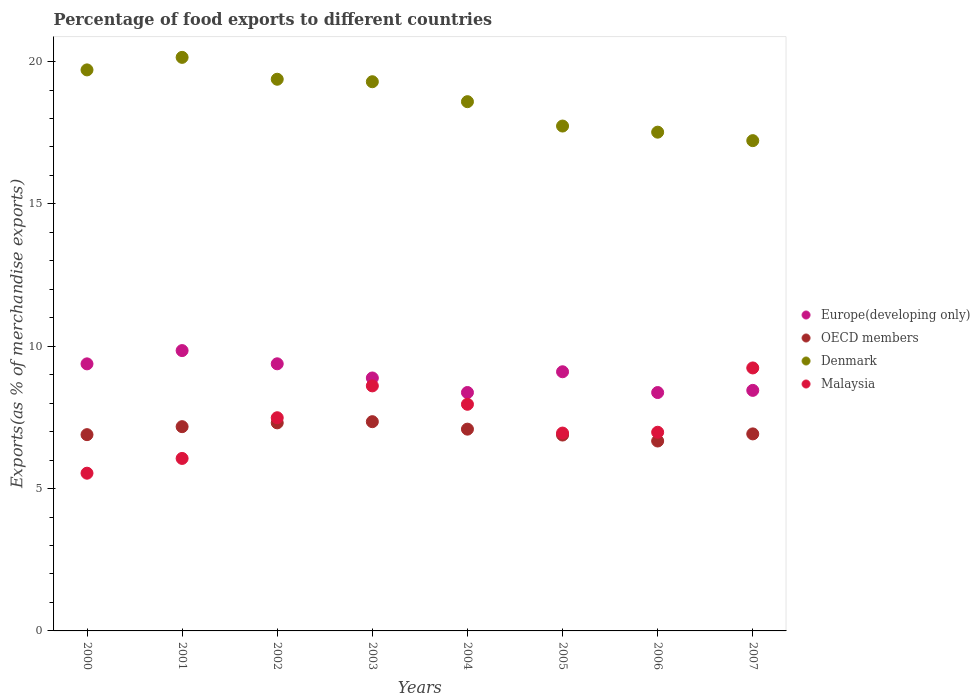What is the percentage of exports to different countries in Malaysia in 2000?
Your answer should be very brief. 5.54. Across all years, what is the maximum percentage of exports to different countries in Denmark?
Provide a succinct answer. 20.15. Across all years, what is the minimum percentage of exports to different countries in Denmark?
Provide a short and direct response. 17.22. In which year was the percentage of exports to different countries in Denmark maximum?
Offer a very short reply. 2001. What is the total percentage of exports to different countries in OECD members in the graph?
Offer a terse response. 56.29. What is the difference between the percentage of exports to different countries in Malaysia in 2001 and that in 2003?
Offer a terse response. -2.55. What is the difference between the percentage of exports to different countries in Malaysia in 2001 and the percentage of exports to different countries in Europe(developing only) in 2007?
Your answer should be compact. -2.39. What is the average percentage of exports to different countries in Europe(developing only) per year?
Give a very brief answer. 8.97. In the year 2001, what is the difference between the percentage of exports to different countries in Denmark and percentage of exports to different countries in OECD members?
Offer a very short reply. 12.97. What is the ratio of the percentage of exports to different countries in Malaysia in 2001 to that in 2007?
Provide a short and direct response. 0.66. Is the percentage of exports to different countries in Malaysia in 2000 less than that in 2007?
Provide a short and direct response. Yes. What is the difference between the highest and the second highest percentage of exports to different countries in OECD members?
Ensure brevity in your answer.  0.04. What is the difference between the highest and the lowest percentage of exports to different countries in Europe(developing only)?
Your answer should be compact. 1.47. Is the sum of the percentage of exports to different countries in Malaysia in 2006 and 2007 greater than the maximum percentage of exports to different countries in Denmark across all years?
Ensure brevity in your answer.  No. Is it the case that in every year, the sum of the percentage of exports to different countries in Europe(developing only) and percentage of exports to different countries in OECD members  is greater than the sum of percentage of exports to different countries in Denmark and percentage of exports to different countries in Malaysia?
Provide a short and direct response. Yes. Is the percentage of exports to different countries in Europe(developing only) strictly greater than the percentage of exports to different countries in Denmark over the years?
Give a very brief answer. No. How many years are there in the graph?
Your response must be concise. 8. Does the graph contain grids?
Your answer should be very brief. No. Where does the legend appear in the graph?
Your answer should be very brief. Center right. What is the title of the graph?
Ensure brevity in your answer.  Percentage of food exports to different countries. Does "Morocco" appear as one of the legend labels in the graph?
Offer a terse response. No. What is the label or title of the Y-axis?
Keep it short and to the point. Exports(as % of merchandise exports). What is the Exports(as % of merchandise exports) of Europe(developing only) in 2000?
Offer a terse response. 9.38. What is the Exports(as % of merchandise exports) in OECD members in 2000?
Offer a very short reply. 6.89. What is the Exports(as % of merchandise exports) in Denmark in 2000?
Make the answer very short. 19.71. What is the Exports(as % of merchandise exports) of Malaysia in 2000?
Offer a very short reply. 5.54. What is the Exports(as % of merchandise exports) of Europe(developing only) in 2001?
Offer a very short reply. 9.85. What is the Exports(as % of merchandise exports) in OECD members in 2001?
Your answer should be compact. 7.17. What is the Exports(as % of merchandise exports) of Denmark in 2001?
Make the answer very short. 20.15. What is the Exports(as % of merchandise exports) of Malaysia in 2001?
Give a very brief answer. 6.06. What is the Exports(as % of merchandise exports) in Europe(developing only) in 2002?
Give a very brief answer. 9.38. What is the Exports(as % of merchandise exports) of OECD members in 2002?
Ensure brevity in your answer.  7.31. What is the Exports(as % of merchandise exports) in Denmark in 2002?
Your answer should be very brief. 19.38. What is the Exports(as % of merchandise exports) in Malaysia in 2002?
Make the answer very short. 7.49. What is the Exports(as % of merchandise exports) of Europe(developing only) in 2003?
Ensure brevity in your answer.  8.89. What is the Exports(as % of merchandise exports) of OECD members in 2003?
Your answer should be very brief. 7.35. What is the Exports(as % of merchandise exports) of Denmark in 2003?
Provide a short and direct response. 19.29. What is the Exports(as % of merchandise exports) in Malaysia in 2003?
Provide a succinct answer. 8.61. What is the Exports(as % of merchandise exports) in Europe(developing only) in 2004?
Your answer should be compact. 8.37. What is the Exports(as % of merchandise exports) of OECD members in 2004?
Your response must be concise. 7.09. What is the Exports(as % of merchandise exports) of Denmark in 2004?
Make the answer very short. 18.59. What is the Exports(as % of merchandise exports) in Malaysia in 2004?
Ensure brevity in your answer.  7.96. What is the Exports(as % of merchandise exports) in Europe(developing only) in 2005?
Provide a short and direct response. 9.1. What is the Exports(as % of merchandise exports) of OECD members in 2005?
Your answer should be very brief. 6.88. What is the Exports(as % of merchandise exports) in Denmark in 2005?
Offer a terse response. 17.73. What is the Exports(as % of merchandise exports) of Malaysia in 2005?
Your response must be concise. 6.95. What is the Exports(as % of merchandise exports) in Europe(developing only) in 2006?
Make the answer very short. 8.37. What is the Exports(as % of merchandise exports) of OECD members in 2006?
Provide a short and direct response. 6.67. What is the Exports(as % of merchandise exports) in Denmark in 2006?
Ensure brevity in your answer.  17.52. What is the Exports(as % of merchandise exports) in Malaysia in 2006?
Your answer should be compact. 6.98. What is the Exports(as % of merchandise exports) of Europe(developing only) in 2007?
Offer a very short reply. 8.45. What is the Exports(as % of merchandise exports) of OECD members in 2007?
Ensure brevity in your answer.  6.92. What is the Exports(as % of merchandise exports) of Denmark in 2007?
Provide a short and direct response. 17.22. What is the Exports(as % of merchandise exports) of Malaysia in 2007?
Give a very brief answer. 9.24. Across all years, what is the maximum Exports(as % of merchandise exports) of Europe(developing only)?
Make the answer very short. 9.85. Across all years, what is the maximum Exports(as % of merchandise exports) of OECD members?
Provide a succinct answer. 7.35. Across all years, what is the maximum Exports(as % of merchandise exports) of Denmark?
Your answer should be very brief. 20.15. Across all years, what is the maximum Exports(as % of merchandise exports) of Malaysia?
Make the answer very short. 9.24. Across all years, what is the minimum Exports(as % of merchandise exports) of Europe(developing only)?
Keep it short and to the point. 8.37. Across all years, what is the minimum Exports(as % of merchandise exports) of OECD members?
Your answer should be very brief. 6.67. Across all years, what is the minimum Exports(as % of merchandise exports) in Denmark?
Keep it short and to the point. 17.22. Across all years, what is the minimum Exports(as % of merchandise exports) in Malaysia?
Give a very brief answer. 5.54. What is the total Exports(as % of merchandise exports) of Europe(developing only) in the graph?
Provide a short and direct response. 71.8. What is the total Exports(as % of merchandise exports) of OECD members in the graph?
Keep it short and to the point. 56.29. What is the total Exports(as % of merchandise exports) in Denmark in the graph?
Your answer should be very brief. 149.59. What is the total Exports(as % of merchandise exports) of Malaysia in the graph?
Ensure brevity in your answer.  58.82. What is the difference between the Exports(as % of merchandise exports) in Europe(developing only) in 2000 and that in 2001?
Provide a short and direct response. -0.47. What is the difference between the Exports(as % of merchandise exports) of OECD members in 2000 and that in 2001?
Make the answer very short. -0.28. What is the difference between the Exports(as % of merchandise exports) of Denmark in 2000 and that in 2001?
Your answer should be compact. -0.44. What is the difference between the Exports(as % of merchandise exports) in Malaysia in 2000 and that in 2001?
Keep it short and to the point. -0.52. What is the difference between the Exports(as % of merchandise exports) of Europe(developing only) in 2000 and that in 2002?
Offer a terse response. -0. What is the difference between the Exports(as % of merchandise exports) of OECD members in 2000 and that in 2002?
Your answer should be very brief. -0.41. What is the difference between the Exports(as % of merchandise exports) of Denmark in 2000 and that in 2002?
Your answer should be compact. 0.33. What is the difference between the Exports(as % of merchandise exports) of Malaysia in 2000 and that in 2002?
Your answer should be compact. -1.95. What is the difference between the Exports(as % of merchandise exports) of Europe(developing only) in 2000 and that in 2003?
Your answer should be compact. 0.5. What is the difference between the Exports(as % of merchandise exports) of OECD members in 2000 and that in 2003?
Offer a terse response. -0.46. What is the difference between the Exports(as % of merchandise exports) in Denmark in 2000 and that in 2003?
Make the answer very short. 0.42. What is the difference between the Exports(as % of merchandise exports) in Malaysia in 2000 and that in 2003?
Provide a short and direct response. -3.07. What is the difference between the Exports(as % of merchandise exports) in OECD members in 2000 and that in 2004?
Make the answer very short. -0.19. What is the difference between the Exports(as % of merchandise exports) in Denmark in 2000 and that in 2004?
Give a very brief answer. 1.12. What is the difference between the Exports(as % of merchandise exports) of Malaysia in 2000 and that in 2004?
Your answer should be compact. -2.42. What is the difference between the Exports(as % of merchandise exports) of Europe(developing only) in 2000 and that in 2005?
Offer a very short reply. 0.28. What is the difference between the Exports(as % of merchandise exports) in OECD members in 2000 and that in 2005?
Your answer should be very brief. 0.01. What is the difference between the Exports(as % of merchandise exports) in Denmark in 2000 and that in 2005?
Offer a very short reply. 1.97. What is the difference between the Exports(as % of merchandise exports) in Malaysia in 2000 and that in 2005?
Provide a short and direct response. -1.41. What is the difference between the Exports(as % of merchandise exports) of Europe(developing only) in 2000 and that in 2006?
Provide a short and direct response. 1.01. What is the difference between the Exports(as % of merchandise exports) of OECD members in 2000 and that in 2006?
Provide a short and direct response. 0.22. What is the difference between the Exports(as % of merchandise exports) in Denmark in 2000 and that in 2006?
Your response must be concise. 2.19. What is the difference between the Exports(as % of merchandise exports) of Malaysia in 2000 and that in 2006?
Your answer should be compact. -1.44. What is the difference between the Exports(as % of merchandise exports) in Europe(developing only) in 2000 and that in 2007?
Provide a short and direct response. 0.93. What is the difference between the Exports(as % of merchandise exports) of OECD members in 2000 and that in 2007?
Give a very brief answer. -0.03. What is the difference between the Exports(as % of merchandise exports) in Denmark in 2000 and that in 2007?
Give a very brief answer. 2.49. What is the difference between the Exports(as % of merchandise exports) in Malaysia in 2000 and that in 2007?
Provide a short and direct response. -3.7. What is the difference between the Exports(as % of merchandise exports) of Europe(developing only) in 2001 and that in 2002?
Give a very brief answer. 0.46. What is the difference between the Exports(as % of merchandise exports) of OECD members in 2001 and that in 2002?
Keep it short and to the point. -0.13. What is the difference between the Exports(as % of merchandise exports) in Denmark in 2001 and that in 2002?
Keep it short and to the point. 0.77. What is the difference between the Exports(as % of merchandise exports) of Malaysia in 2001 and that in 2002?
Your answer should be compact. -1.43. What is the difference between the Exports(as % of merchandise exports) in Europe(developing only) in 2001 and that in 2003?
Your response must be concise. 0.96. What is the difference between the Exports(as % of merchandise exports) of OECD members in 2001 and that in 2003?
Provide a succinct answer. -0.18. What is the difference between the Exports(as % of merchandise exports) of Denmark in 2001 and that in 2003?
Offer a very short reply. 0.86. What is the difference between the Exports(as % of merchandise exports) in Malaysia in 2001 and that in 2003?
Offer a very short reply. -2.55. What is the difference between the Exports(as % of merchandise exports) in Europe(developing only) in 2001 and that in 2004?
Make the answer very short. 1.47. What is the difference between the Exports(as % of merchandise exports) in OECD members in 2001 and that in 2004?
Provide a succinct answer. 0.09. What is the difference between the Exports(as % of merchandise exports) of Denmark in 2001 and that in 2004?
Give a very brief answer. 1.56. What is the difference between the Exports(as % of merchandise exports) of Malaysia in 2001 and that in 2004?
Your answer should be compact. -1.9. What is the difference between the Exports(as % of merchandise exports) of Europe(developing only) in 2001 and that in 2005?
Provide a succinct answer. 0.74. What is the difference between the Exports(as % of merchandise exports) in OECD members in 2001 and that in 2005?
Provide a succinct answer. 0.29. What is the difference between the Exports(as % of merchandise exports) of Denmark in 2001 and that in 2005?
Provide a succinct answer. 2.41. What is the difference between the Exports(as % of merchandise exports) of Malaysia in 2001 and that in 2005?
Give a very brief answer. -0.89. What is the difference between the Exports(as % of merchandise exports) of Europe(developing only) in 2001 and that in 2006?
Provide a short and direct response. 1.47. What is the difference between the Exports(as % of merchandise exports) in OECD members in 2001 and that in 2006?
Your response must be concise. 0.5. What is the difference between the Exports(as % of merchandise exports) of Denmark in 2001 and that in 2006?
Make the answer very short. 2.63. What is the difference between the Exports(as % of merchandise exports) of Malaysia in 2001 and that in 2006?
Provide a succinct answer. -0.92. What is the difference between the Exports(as % of merchandise exports) in Europe(developing only) in 2001 and that in 2007?
Give a very brief answer. 1.4. What is the difference between the Exports(as % of merchandise exports) in OECD members in 2001 and that in 2007?
Offer a very short reply. 0.25. What is the difference between the Exports(as % of merchandise exports) of Denmark in 2001 and that in 2007?
Keep it short and to the point. 2.93. What is the difference between the Exports(as % of merchandise exports) of Malaysia in 2001 and that in 2007?
Offer a very short reply. -3.18. What is the difference between the Exports(as % of merchandise exports) of Europe(developing only) in 2002 and that in 2003?
Keep it short and to the point. 0.5. What is the difference between the Exports(as % of merchandise exports) of OECD members in 2002 and that in 2003?
Ensure brevity in your answer.  -0.04. What is the difference between the Exports(as % of merchandise exports) of Denmark in 2002 and that in 2003?
Offer a terse response. 0.09. What is the difference between the Exports(as % of merchandise exports) in Malaysia in 2002 and that in 2003?
Provide a succinct answer. -1.12. What is the difference between the Exports(as % of merchandise exports) of Europe(developing only) in 2002 and that in 2004?
Your answer should be very brief. 1.01. What is the difference between the Exports(as % of merchandise exports) in OECD members in 2002 and that in 2004?
Provide a short and direct response. 0.22. What is the difference between the Exports(as % of merchandise exports) in Denmark in 2002 and that in 2004?
Your response must be concise. 0.79. What is the difference between the Exports(as % of merchandise exports) of Malaysia in 2002 and that in 2004?
Provide a succinct answer. -0.47. What is the difference between the Exports(as % of merchandise exports) of Europe(developing only) in 2002 and that in 2005?
Make the answer very short. 0.28. What is the difference between the Exports(as % of merchandise exports) of OECD members in 2002 and that in 2005?
Offer a terse response. 0.43. What is the difference between the Exports(as % of merchandise exports) of Denmark in 2002 and that in 2005?
Provide a short and direct response. 1.64. What is the difference between the Exports(as % of merchandise exports) of Malaysia in 2002 and that in 2005?
Offer a very short reply. 0.54. What is the difference between the Exports(as % of merchandise exports) in Europe(developing only) in 2002 and that in 2006?
Your response must be concise. 1.01. What is the difference between the Exports(as % of merchandise exports) in OECD members in 2002 and that in 2006?
Your response must be concise. 0.64. What is the difference between the Exports(as % of merchandise exports) of Denmark in 2002 and that in 2006?
Your answer should be very brief. 1.86. What is the difference between the Exports(as % of merchandise exports) of Malaysia in 2002 and that in 2006?
Offer a terse response. 0.51. What is the difference between the Exports(as % of merchandise exports) in Europe(developing only) in 2002 and that in 2007?
Your answer should be compact. 0.93. What is the difference between the Exports(as % of merchandise exports) of OECD members in 2002 and that in 2007?
Your answer should be compact. 0.39. What is the difference between the Exports(as % of merchandise exports) in Denmark in 2002 and that in 2007?
Your response must be concise. 2.16. What is the difference between the Exports(as % of merchandise exports) in Malaysia in 2002 and that in 2007?
Provide a succinct answer. -1.75. What is the difference between the Exports(as % of merchandise exports) of Europe(developing only) in 2003 and that in 2004?
Provide a short and direct response. 0.51. What is the difference between the Exports(as % of merchandise exports) of OECD members in 2003 and that in 2004?
Your answer should be very brief. 0.26. What is the difference between the Exports(as % of merchandise exports) in Denmark in 2003 and that in 2004?
Keep it short and to the point. 0.7. What is the difference between the Exports(as % of merchandise exports) of Malaysia in 2003 and that in 2004?
Give a very brief answer. 0.65. What is the difference between the Exports(as % of merchandise exports) of Europe(developing only) in 2003 and that in 2005?
Give a very brief answer. -0.22. What is the difference between the Exports(as % of merchandise exports) in OECD members in 2003 and that in 2005?
Keep it short and to the point. 0.47. What is the difference between the Exports(as % of merchandise exports) in Denmark in 2003 and that in 2005?
Offer a terse response. 1.56. What is the difference between the Exports(as % of merchandise exports) of Malaysia in 2003 and that in 2005?
Your answer should be very brief. 1.66. What is the difference between the Exports(as % of merchandise exports) in Europe(developing only) in 2003 and that in 2006?
Your answer should be very brief. 0.51. What is the difference between the Exports(as % of merchandise exports) of OECD members in 2003 and that in 2006?
Offer a terse response. 0.68. What is the difference between the Exports(as % of merchandise exports) of Denmark in 2003 and that in 2006?
Provide a short and direct response. 1.77. What is the difference between the Exports(as % of merchandise exports) of Malaysia in 2003 and that in 2006?
Give a very brief answer. 1.63. What is the difference between the Exports(as % of merchandise exports) in Europe(developing only) in 2003 and that in 2007?
Your answer should be compact. 0.44. What is the difference between the Exports(as % of merchandise exports) of OECD members in 2003 and that in 2007?
Your answer should be compact. 0.43. What is the difference between the Exports(as % of merchandise exports) in Denmark in 2003 and that in 2007?
Your response must be concise. 2.07. What is the difference between the Exports(as % of merchandise exports) in Malaysia in 2003 and that in 2007?
Your answer should be compact. -0.63. What is the difference between the Exports(as % of merchandise exports) of Europe(developing only) in 2004 and that in 2005?
Your response must be concise. -0.73. What is the difference between the Exports(as % of merchandise exports) of OECD members in 2004 and that in 2005?
Offer a terse response. 0.21. What is the difference between the Exports(as % of merchandise exports) of Denmark in 2004 and that in 2005?
Offer a terse response. 0.86. What is the difference between the Exports(as % of merchandise exports) in Malaysia in 2004 and that in 2005?
Offer a very short reply. 1.01. What is the difference between the Exports(as % of merchandise exports) of Europe(developing only) in 2004 and that in 2006?
Keep it short and to the point. 0. What is the difference between the Exports(as % of merchandise exports) in OECD members in 2004 and that in 2006?
Give a very brief answer. 0.42. What is the difference between the Exports(as % of merchandise exports) of Denmark in 2004 and that in 2006?
Provide a succinct answer. 1.07. What is the difference between the Exports(as % of merchandise exports) in Malaysia in 2004 and that in 2006?
Provide a succinct answer. 0.98. What is the difference between the Exports(as % of merchandise exports) of Europe(developing only) in 2004 and that in 2007?
Offer a very short reply. -0.07. What is the difference between the Exports(as % of merchandise exports) in OECD members in 2004 and that in 2007?
Provide a short and direct response. 0.17. What is the difference between the Exports(as % of merchandise exports) of Denmark in 2004 and that in 2007?
Your answer should be compact. 1.37. What is the difference between the Exports(as % of merchandise exports) of Malaysia in 2004 and that in 2007?
Give a very brief answer. -1.28. What is the difference between the Exports(as % of merchandise exports) in Europe(developing only) in 2005 and that in 2006?
Ensure brevity in your answer.  0.73. What is the difference between the Exports(as % of merchandise exports) in OECD members in 2005 and that in 2006?
Your answer should be very brief. 0.21. What is the difference between the Exports(as % of merchandise exports) of Denmark in 2005 and that in 2006?
Keep it short and to the point. 0.21. What is the difference between the Exports(as % of merchandise exports) of Malaysia in 2005 and that in 2006?
Offer a terse response. -0.03. What is the difference between the Exports(as % of merchandise exports) of Europe(developing only) in 2005 and that in 2007?
Ensure brevity in your answer.  0.65. What is the difference between the Exports(as % of merchandise exports) of OECD members in 2005 and that in 2007?
Provide a succinct answer. -0.04. What is the difference between the Exports(as % of merchandise exports) of Denmark in 2005 and that in 2007?
Provide a succinct answer. 0.51. What is the difference between the Exports(as % of merchandise exports) of Malaysia in 2005 and that in 2007?
Your answer should be compact. -2.29. What is the difference between the Exports(as % of merchandise exports) in Europe(developing only) in 2006 and that in 2007?
Your answer should be compact. -0.08. What is the difference between the Exports(as % of merchandise exports) of OECD members in 2006 and that in 2007?
Your answer should be compact. -0.25. What is the difference between the Exports(as % of merchandise exports) in Denmark in 2006 and that in 2007?
Make the answer very short. 0.3. What is the difference between the Exports(as % of merchandise exports) in Malaysia in 2006 and that in 2007?
Your response must be concise. -2.26. What is the difference between the Exports(as % of merchandise exports) in Europe(developing only) in 2000 and the Exports(as % of merchandise exports) in OECD members in 2001?
Offer a very short reply. 2.21. What is the difference between the Exports(as % of merchandise exports) in Europe(developing only) in 2000 and the Exports(as % of merchandise exports) in Denmark in 2001?
Keep it short and to the point. -10.77. What is the difference between the Exports(as % of merchandise exports) of Europe(developing only) in 2000 and the Exports(as % of merchandise exports) of Malaysia in 2001?
Ensure brevity in your answer.  3.32. What is the difference between the Exports(as % of merchandise exports) of OECD members in 2000 and the Exports(as % of merchandise exports) of Denmark in 2001?
Your response must be concise. -13.25. What is the difference between the Exports(as % of merchandise exports) in OECD members in 2000 and the Exports(as % of merchandise exports) in Malaysia in 2001?
Provide a succinct answer. 0.84. What is the difference between the Exports(as % of merchandise exports) of Denmark in 2000 and the Exports(as % of merchandise exports) of Malaysia in 2001?
Give a very brief answer. 13.65. What is the difference between the Exports(as % of merchandise exports) of Europe(developing only) in 2000 and the Exports(as % of merchandise exports) of OECD members in 2002?
Your answer should be compact. 2.07. What is the difference between the Exports(as % of merchandise exports) in Europe(developing only) in 2000 and the Exports(as % of merchandise exports) in Denmark in 2002?
Keep it short and to the point. -10. What is the difference between the Exports(as % of merchandise exports) of Europe(developing only) in 2000 and the Exports(as % of merchandise exports) of Malaysia in 2002?
Your answer should be very brief. 1.89. What is the difference between the Exports(as % of merchandise exports) of OECD members in 2000 and the Exports(as % of merchandise exports) of Denmark in 2002?
Your answer should be very brief. -12.48. What is the difference between the Exports(as % of merchandise exports) in OECD members in 2000 and the Exports(as % of merchandise exports) in Malaysia in 2002?
Make the answer very short. -0.59. What is the difference between the Exports(as % of merchandise exports) in Denmark in 2000 and the Exports(as % of merchandise exports) in Malaysia in 2002?
Provide a succinct answer. 12.22. What is the difference between the Exports(as % of merchandise exports) in Europe(developing only) in 2000 and the Exports(as % of merchandise exports) in OECD members in 2003?
Provide a short and direct response. 2.03. What is the difference between the Exports(as % of merchandise exports) in Europe(developing only) in 2000 and the Exports(as % of merchandise exports) in Denmark in 2003?
Ensure brevity in your answer.  -9.91. What is the difference between the Exports(as % of merchandise exports) in Europe(developing only) in 2000 and the Exports(as % of merchandise exports) in Malaysia in 2003?
Ensure brevity in your answer.  0.77. What is the difference between the Exports(as % of merchandise exports) of OECD members in 2000 and the Exports(as % of merchandise exports) of Denmark in 2003?
Your response must be concise. -12.4. What is the difference between the Exports(as % of merchandise exports) of OECD members in 2000 and the Exports(as % of merchandise exports) of Malaysia in 2003?
Your answer should be compact. -1.71. What is the difference between the Exports(as % of merchandise exports) in Denmark in 2000 and the Exports(as % of merchandise exports) in Malaysia in 2003?
Your response must be concise. 11.1. What is the difference between the Exports(as % of merchandise exports) in Europe(developing only) in 2000 and the Exports(as % of merchandise exports) in OECD members in 2004?
Offer a terse response. 2.29. What is the difference between the Exports(as % of merchandise exports) of Europe(developing only) in 2000 and the Exports(as % of merchandise exports) of Denmark in 2004?
Provide a short and direct response. -9.21. What is the difference between the Exports(as % of merchandise exports) in Europe(developing only) in 2000 and the Exports(as % of merchandise exports) in Malaysia in 2004?
Offer a terse response. 1.42. What is the difference between the Exports(as % of merchandise exports) in OECD members in 2000 and the Exports(as % of merchandise exports) in Denmark in 2004?
Provide a succinct answer. -11.7. What is the difference between the Exports(as % of merchandise exports) in OECD members in 2000 and the Exports(as % of merchandise exports) in Malaysia in 2004?
Provide a succinct answer. -1.07. What is the difference between the Exports(as % of merchandise exports) in Denmark in 2000 and the Exports(as % of merchandise exports) in Malaysia in 2004?
Your response must be concise. 11.75. What is the difference between the Exports(as % of merchandise exports) in Europe(developing only) in 2000 and the Exports(as % of merchandise exports) in OECD members in 2005?
Ensure brevity in your answer.  2.5. What is the difference between the Exports(as % of merchandise exports) in Europe(developing only) in 2000 and the Exports(as % of merchandise exports) in Denmark in 2005?
Your answer should be compact. -8.35. What is the difference between the Exports(as % of merchandise exports) of Europe(developing only) in 2000 and the Exports(as % of merchandise exports) of Malaysia in 2005?
Your response must be concise. 2.43. What is the difference between the Exports(as % of merchandise exports) of OECD members in 2000 and the Exports(as % of merchandise exports) of Denmark in 2005?
Offer a terse response. -10.84. What is the difference between the Exports(as % of merchandise exports) in OECD members in 2000 and the Exports(as % of merchandise exports) in Malaysia in 2005?
Make the answer very short. -0.06. What is the difference between the Exports(as % of merchandise exports) of Denmark in 2000 and the Exports(as % of merchandise exports) of Malaysia in 2005?
Keep it short and to the point. 12.76. What is the difference between the Exports(as % of merchandise exports) in Europe(developing only) in 2000 and the Exports(as % of merchandise exports) in OECD members in 2006?
Make the answer very short. 2.71. What is the difference between the Exports(as % of merchandise exports) of Europe(developing only) in 2000 and the Exports(as % of merchandise exports) of Denmark in 2006?
Make the answer very short. -8.14. What is the difference between the Exports(as % of merchandise exports) in Europe(developing only) in 2000 and the Exports(as % of merchandise exports) in Malaysia in 2006?
Your answer should be very brief. 2.4. What is the difference between the Exports(as % of merchandise exports) in OECD members in 2000 and the Exports(as % of merchandise exports) in Denmark in 2006?
Give a very brief answer. -10.63. What is the difference between the Exports(as % of merchandise exports) in OECD members in 2000 and the Exports(as % of merchandise exports) in Malaysia in 2006?
Ensure brevity in your answer.  -0.08. What is the difference between the Exports(as % of merchandise exports) in Denmark in 2000 and the Exports(as % of merchandise exports) in Malaysia in 2006?
Your answer should be compact. 12.73. What is the difference between the Exports(as % of merchandise exports) of Europe(developing only) in 2000 and the Exports(as % of merchandise exports) of OECD members in 2007?
Your answer should be very brief. 2.46. What is the difference between the Exports(as % of merchandise exports) of Europe(developing only) in 2000 and the Exports(as % of merchandise exports) of Denmark in 2007?
Your response must be concise. -7.84. What is the difference between the Exports(as % of merchandise exports) of Europe(developing only) in 2000 and the Exports(as % of merchandise exports) of Malaysia in 2007?
Offer a very short reply. 0.14. What is the difference between the Exports(as % of merchandise exports) in OECD members in 2000 and the Exports(as % of merchandise exports) in Denmark in 2007?
Offer a very short reply. -10.33. What is the difference between the Exports(as % of merchandise exports) in OECD members in 2000 and the Exports(as % of merchandise exports) in Malaysia in 2007?
Provide a short and direct response. -2.34. What is the difference between the Exports(as % of merchandise exports) in Denmark in 2000 and the Exports(as % of merchandise exports) in Malaysia in 2007?
Make the answer very short. 10.47. What is the difference between the Exports(as % of merchandise exports) of Europe(developing only) in 2001 and the Exports(as % of merchandise exports) of OECD members in 2002?
Offer a terse response. 2.54. What is the difference between the Exports(as % of merchandise exports) of Europe(developing only) in 2001 and the Exports(as % of merchandise exports) of Denmark in 2002?
Give a very brief answer. -9.53. What is the difference between the Exports(as % of merchandise exports) of Europe(developing only) in 2001 and the Exports(as % of merchandise exports) of Malaysia in 2002?
Your response must be concise. 2.36. What is the difference between the Exports(as % of merchandise exports) of OECD members in 2001 and the Exports(as % of merchandise exports) of Denmark in 2002?
Provide a short and direct response. -12.2. What is the difference between the Exports(as % of merchandise exports) of OECD members in 2001 and the Exports(as % of merchandise exports) of Malaysia in 2002?
Give a very brief answer. -0.31. What is the difference between the Exports(as % of merchandise exports) in Denmark in 2001 and the Exports(as % of merchandise exports) in Malaysia in 2002?
Offer a terse response. 12.66. What is the difference between the Exports(as % of merchandise exports) of Europe(developing only) in 2001 and the Exports(as % of merchandise exports) of OECD members in 2003?
Provide a succinct answer. 2.5. What is the difference between the Exports(as % of merchandise exports) in Europe(developing only) in 2001 and the Exports(as % of merchandise exports) in Denmark in 2003?
Keep it short and to the point. -9.44. What is the difference between the Exports(as % of merchandise exports) of Europe(developing only) in 2001 and the Exports(as % of merchandise exports) of Malaysia in 2003?
Make the answer very short. 1.24. What is the difference between the Exports(as % of merchandise exports) of OECD members in 2001 and the Exports(as % of merchandise exports) of Denmark in 2003?
Ensure brevity in your answer.  -12.12. What is the difference between the Exports(as % of merchandise exports) of OECD members in 2001 and the Exports(as % of merchandise exports) of Malaysia in 2003?
Your answer should be compact. -1.43. What is the difference between the Exports(as % of merchandise exports) of Denmark in 2001 and the Exports(as % of merchandise exports) of Malaysia in 2003?
Your answer should be very brief. 11.54. What is the difference between the Exports(as % of merchandise exports) of Europe(developing only) in 2001 and the Exports(as % of merchandise exports) of OECD members in 2004?
Offer a very short reply. 2.76. What is the difference between the Exports(as % of merchandise exports) of Europe(developing only) in 2001 and the Exports(as % of merchandise exports) of Denmark in 2004?
Your answer should be compact. -8.74. What is the difference between the Exports(as % of merchandise exports) of Europe(developing only) in 2001 and the Exports(as % of merchandise exports) of Malaysia in 2004?
Keep it short and to the point. 1.89. What is the difference between the Exports(as % of merchandise exports) of OECD members in 2001 and the Exports(as % of merchandise exports) of Denmark in 2004?
Make the answer very short. -11.42. What is the difference between the Exports(as % of merchandise exports) of OECD members in 2001 and the Exports(as % of merchandise exports) of Malaysia in 2004?
Offer a terse response. -0.79. What is the difference between the Exports(as % of merchandise exports) in Denmark in 2001 and the Exports(as % of merchandise exports) in Malaysia in 2004?
Your response must be concise. 12.19. What is the difference between the Exports(as % of merchandise exports) in Europe(developing only) in 2001 and the Exports(as % of merchandise exports) in OECD members in 2005?
Offer a very short reply. 2.97. What is the difference between the Exports(as % of merchandise exports) of Europe(developing only) in 2001 and the Exports(as % of merchandise exports) of Denmark in 2005?
Offer a very short reply. -7.89. What is the difference between the Exports(as % of merchandise exports) of Europe(developing only) in 2001 and the Exports(as % of merchandise exports) of Malaysia in 2005?
Provide a short and direct response. 2.9. What is the difference between the Exports(as % of merchandise exports) in OECD members in 2001 and the Exports(as % of merchandise exports) in Denmark in 2005?
Your answer should be very brief. -10.56. What is the difference between the Exports(as % of merchandise exports) of OECD members in 2001 and the Exports(as % of merchandise exports) of Malaysia in 2005?
Keep it short and to the point. 0.22. What is the difference between the Exports(as % of merchandise exports) of Denmark in 2001 and the Exports(as % of merchandise exports) of Malaysia in 2005?
Provide a short and direct response. 13.2. What is the difference between the Exports(as % of merchandise exports) in Europe(developing only) in 2001 and the Exports(as % of merchandise exports) in OECD members in 2006?
Your response must be concise. 3.18. What is the difference between the Exports(as % of merchandise exports) of Europe(developing only) in 2001 and the Exports(as % of merchandise exports) of Denmark in 2006?
Ensure brevity in your answer.  -7.67. What is the difference between the Exports(as % of merchandise exports) of Europe(developing only) in 2001 and the Exports(as % of merchandise exports) of Malaysia in 2006?
Provide a succinct answer. 2.87. What is the difference between the Exports(as % of merchandise exports) in OECD members in 2001 and the Exports(as % of merchandise exports) in Denmark in 2006?
Your answer should be compact. -10.34. What is the difference between the Exports(as % of merchandise exports) in OECD members in 2001 and the Exports(as % of merchandise exports) in Malaysia in 2006?
Give a very brief answer. 0.2. What is the difference between the Exports(as % of merchandise exports) of Denmark in 2001 and the Exports(as % of merchandise exports) of Malaysia in 2006?
Offer a very short reply. 13.17. What is the difference between the Exports(as % of merchandise exports) of Europe(developing only) in 2001 and the Exports(as % of merchandise exports) of OECD members in 2007?
Give a very brief answer. 2.93. What is the difference between the Exports(as % of merchandise exports) in Europe(developing only) in 2001 and the Exports(as % of merchandise exports) in Denmark in 2007?
Your answer should be compact. -7.37. What is the difference between the Exports(as % of merchandise exports) in Europe(developing only) in 2001 and the Exports(as % of merchandise exports) in Malaysia in 2007?
Your answer should be compact. 0.61. What is the difference between the Exports(as % of merchandise exports) in OECD members in 2001 and the Exports(as % of merchandise exports) in Denmark in 2007?
Ensure brevity in your answer.  -10.05. What is the difference between the Exports(as % of merchandise exports) of OECD members in 2001 and the Exports(as % of merchandise exports) of Malaysia in 2007?
Offer a terse response. -2.06. What is the difference between the Exports(as % of merchandise exports) in Denmark in 2001 and the Exports(as % of merchandise exports) in Malaysia in 2007?
Provide a succinct answer. 10.91. What is the difference between the Exports(as % of merchandise exports) of Europe(developing only) in 2002 and the Exports(as % of merchandise exports) of OECD members in 2003?
Offer a terse response. 2.03. What is the difference between the Exports(as % of merchandise exports) in Europe(developing only) in 2002 and the Exports(as % of merchandise exports) in Denmark in 2003?
Make the answer very short. -9.91. What is the difference between the Exports(as % of merchandise exports) of Europe(developing only) in 2002 and the Exports(as % of merchandise exports) of Malaysia in 2003?
Your answer should be very brief. 0.78. What is the difference between the Exports(as % of merchandise exports) of OECD members in 2002 and the Exports(as % of merchandise exports) of Denmark in 2003?
Your answer should be compact. -11.98. What is the difference between the Exports(as % of merchandise exports) of OECD members in 2002 and the Exports(as % of merchandise exports) of Malaysia in 2003?
Your answer should be compact. -1.3. What is the difference between the Exports(as % of merchandise exports) of Denmark in 2002 and the Exports(as % of merchandise exports) of Malaysia in 2003?
Give a very brief answer. 10.77. What is the difference between the Exports(as % of merchandise exports) in Europe(developing only) in 2002 and the Exports(as % of merchandise exports) in OECD members in 2004?
Your answer should be very brief. 2.3. What is the difference between the Exports(as % of merchandise exports) in Europe(developing only) in 2002 and the Exports(as % of merchandise exports) in Denmark in 2004?
Keep it short and to the point. -9.21. What is the difference between the Exports(as % of merchandise exports) in Europe(developing only) in 2002 and the Exports(as % of merchandise exports) in Malaysia in 2004?
Keep it short and to the point. 1.42. What is the difference between the Exports(as % of merchandise exports) of OECD members in 2002 and the Exports(as % of merchandise exports) of Denmark in 2004?
Your response must be concise. -11.28. What is the difference between the Exports(as % of merchandise exports) of OECD members in 2002 and the Exports(as % of merchandise exports) of Malaysia in 2004?
Your answer should be very brief. -0.65. What is the difference between the Exports(as % of merchandise exports) of Denmark in 2002 and the Exports(as % of merchandise exports) of Malaysia in 2004?
Provide a short and direct response. 11.42. What is the difference between the Exports(as % of merchandise exports) of Europe(developing only) in 2002 and the Exports(as % of merchandise exports) of OECD members in 2005?
Provide a short and direct response. 2.5. What is the difference between the Exports(as % of merchandise exports) of Europe(developing only) in 2002 and the Exports(as % of merchandise exports) of Denmark in 2005?
Provide a succinct answer. -8.35. What is the difference between the Exports(as % of merchandise exports) in Europe(developing only) in 2002 and the Exports(as % of merchandise exports) in Malaysia in 2005?
Make the answer very short. 2.43. What is the difference between the Exports(as % of merchandise exports) in OECD members in 2002 and the Exports(as % of merchandise exports) in Denmark in 2005?
Make the answer very short. -10.43. What is the difference between the Exports(as % of merchandise exports) of OECD members in 2002 and the Exports(as % of merchandise exports) of Malaysia in 2005?
Provide a short and direct response. 0.36. What is the difference between the Exports(as % of merchandise exports) in Denmark in 2002 and the Exports(as % of merchandise exports) in Malaysia in 2005?
Make the answer very short. 12.43. What is the difference between the Exports(as % of merchandise exports) in Europe(developing only) in 2002 and the Exports(as % of merchandise exports) in OECD members in 2006?
Offer a terse response. 2.71. What is the difference between the Exports(as % of merchandise exports) in Europe(developing only) in 2002 and the Exports(as % of merchandise exports) in Denmark in 2006?
Offer a terse response. -8.14. What is the difference between the Exports(as % of merchandise exports) in Europe(developing only) in 2002 and the Exports(as % of merchandise exports) in Malaysia in 2006?
Ensure brevity in your answer.  2.4. What is the difference between the Exports(as % of merchandise exports) of OECD members in 2002 and the Exports(as % of merchandise exports) of Denmark in 2006?
Give a very brief answer. -10.21. What is the difference between the Exports(as % of merchandise exports) of OECD members in 2002 and the Exports(as % of merchandise exports) of Malaysia in 2006?
Keep it short and to the point. 0.33. What is the difference between the Exports(as % of merchandise exports) in Denmark in 2002 and the Exports(as % of merchandise exports) in Malaysia in 2006?
Offer a terse response. 12.4. What is the difference between the Exports(as % of merchandise exports) in Europe(developing only) in 2002 and the Exports(as % of merchandise exports) in OECD members in 2007?
Offer a terse response. 2.46. What is the difference between the Exports(as % of merchandise exports) of Europe(developing only) in 2002 and the Exports(as % of merchandise exports) of Denmark in 2007?
Provide a succinct answer. -7.84. What is the difference between the Exports(as % of merchandise exports) of Europe(developing only) in 2002 and the Exports(as % of merchandise exports) of Malaysia in 2007?
Make the answer very short. 0.15. What is the difference between the Exports(as % of merchandise exports) in OECD members in 2002 and the Exports(as % of merchandise exports) in Denmark in 2007?
Offer a very short reply. -9.91. What is the difference between the Exports(as % of merchandise exports) of OECD members in 2002 and the Exports(as % of merchandise exports) of Malaysia in 2007?
Keep it short and to the point. -1.93. What is the difference between the Exports(as % of merchandise exports) in Denmark in 2002 and the Exports(as % of merchandise exports) in Malaysia in 2007?
Provide a short and direct response. 10.14. What is the difference between the Exports(as % of merchandise exports) in Europe(developing only) in 2003 and the Exports(as % of merchandise exports) in OECD members in 2004?
Provide a short and direct response. 1.8. What is the difference between the Exports(as % of merchandise exports) of Europe(developing only) in 2003 and the Exports(as % of merchandise exports) of Denmark in 2004?
Give a very brief answer. -9.71. What is the difference between the Exports(as % of merchandise exports) in Europe(developing only) in 2003 and the Exports(as % of merchandise exports) in Malaysia in 2004?
Keep it short and to the point. 0.92. What is the difference between the Exports(as % of merchandise exports) in OECD members in 2003 and the Exports(as % of merchandise exports) in Denmark in 2004?
Ensure brevity in your answer.  -11.24. What is the difference between the Exports(as % of merchandise exports) in OECD members in 2003 and the Exports(as % of merchandise exports) in Malaysia in 2004?
Your answer should be very brief. -0.61. What is the difference between the Exports(as % of merchandise exports) in Denmark in 2003 and the Exports(as % of merchandise exports) in Malaysia in 2004?
Offer a terse response. 11.33. What is the difference between the Exports(as % of merchandise exports) in Europe(developing only) in 2003 and the Exports(as % of merchandise exports) in OECD members in 2005?
Your answer should be very brief. 2. What is the difference between the Exports(as % of merchandise exports) of Europe(developing only) in 2003 and the Exports(as % of merchandise exports) of Denmark in 2005?
Your answer should be very brief. -8.85. What is the difference between the Exports(as % of merchandise exports) in Europe(developing only) in 2003 and the Exports(as % of merchandise exports) in Malaysia in 2005?
Your answer should be very brief. 1.94. What is the difference between the Exports(as % of merchandise exports) of OECD members in 2003 and the Exports(as % of merchandise exports) of Denmark in 2005?
Provide a succinct answer. -10.38. What is the difference between the Exports(as % of merchandise exports) in OECD members in 2003 and the Exports(as % of merchandise exports) in Malaysia in 2005?
Offer a very short reply. 0.4. What is the difference between the Exports(as % of merchandise exports) of Denmark in 2003 and the Exports(as % of merchandise exports) of Malaysia in 2005?
Offer a terse response. 12.34. What is the difference between the Exports(as % of merchandise exports) in Europe(developing only) in 2003 and the Exports(as % of merchandise exports) in OECD members in 2006?
Your answer should be very brief. 2.21. What is the difference between the Exports(as % of merchandise exports) of Europe(developing only) in 2003 and the Exports(as % of merchandise exports) of Denmark in 2006?
Your answer should be compact. -8.63. What is the difference between the Exports(as % of merchandise exports) in Europe(developing only) in 2003 and the Exports(as % of merchandise exports) in Malaysia in 2006?
Provide a succinct answer. 1.91. What is the difference between the Exports(as % of merchandise exports) in OECD members in 2003 and the Exports(as % of merchandise exports) in Denmark in 2006?
Offer a terse response. -10.17. What is the difference between the Exports(as % of merchandise exports) in OECD members in 2003 and the Exports(as % of merchandise exports) in Malaysia in 2006?
Make the answer very short. 0.37. What is the difference between the Exports(as % of merchandise exports) in Denmark in 2003 and the Exports(as % of merchandise exports) in Malaysia in 2006?
Offer a terse response. 12.31. What is the difference between the Exports(as % of merchandise exports) of Europe(developing only) in 2003 and the Exports(as % of merchandise exports) of OECD members in 2007?
Provide a short and direct response. 1.96. What is the difference between the Exports(as % of merchandise exports) of Europe(developing only) in 2003 and the Exports(as % of merchandise exports) of Denmark in 2007?
Keep it short and to the point. -8.34. What is the difference between the Exports(as % of merchandise exports) of Europe(developing only) in 2003 and the Exports(as % of merchandise exports) of Malaysia in 2007?
Offer a terse response. -0.35. What is the difference between the Exports(as % of merchandise exports) of OECD members in 2003 and the Exports(as % of merchandise exports) of Denmark in 2007?
Give a very brief answer. -9.87. What is the difference between the Exports(as % of merchandise exports) in OECD members in 2003 and the Exports(as % of merchandise exports) in Malaysia in 2007?
Your answer should be compact. -1.89. What is the difference between the Exports(as % of merchandise exports) of Denmark in 2003 and the Exports(as % of merchandise exports) of Malaysia in 2007?
Offer a terse response. 10.05. What is the difference between the Exports(as % of merchandise exports) of Europe(developing only) in 2004 and the Exports(as % of merchandise exports) of OECD members in 2005?
Make the answer very short. 1.49. What is the difference between the Exports(as % of merchandise exports) of Europe(developing only) in 2004 and the Exports(as % of merchandise exports) of Denmark in 2005?
Provide a short and direct response. -9.36. What is the difference between the Exports(as % of merchandise exports) of Europe(developing only) in 2004 and the Exports(as % of merchandise exports) of Malaysia in 2005?
Your response must be concise. 1.42. What is the difference between the Exports(as % of merchandise exports) in OECD members in 2004 and the Exports(as % of merchandise exports) in Denmark in 2005?
Your response must be concise. -10.65. What is the difference between the Exports(as % of merchandise exports) of OECD members in 2004 and the Exports(as % of merchandise exports) of Malaysia in 2005?
Offer a terse response. 0.14. What is the difference between the Exports(as % of merchandise exports) in Denmark in 2004 and the Exports(as % of merchandise exports) in Malaysia in 2005?
Offer a very short reply. 11.64. What is the difference between the Exports(as % of merchandise exports) in Europe(developing only) in 2004 and the Exports(as % of merchandise exports) in OECD members in 2006?
Ensure brevity in your answer.  1.7. What is the difference between the Exports(as % of merchandise exports) in Europe(developing only) in 2004 and the Exports(as % of merchandise exports) in Denmark in 2006?
Provide a short and direct response. -9.14. What is the difference between the Exports(as % of merchandise exports) in Europe(developing only) in 2004 and the Exports(as % of merchandise exports) in Malaysia in 2006?
Ensure brevity in your answer.  1.4. What is the difference between the Exports(as % of merchandise exports) in OECD members in 2004 and the Exports(as % of merchandise exports) in Denmark in 2006?
Provide a succinct answer. -10.43. What is the difference between the Exports(as % of merchandise exports) in OECD members in 2004 and the Exports(as % of merchandise exports) in Malaysia in 2006?
Make the answer very short. 0.11. What is the difference between the Exports(as % of merchandise exports) of Denmark in 2004 and the Exports(as % of merchandise exports) of Malaysia in 2006?
Offer a very short reply. 11.61. What is the difference between the Exports(as % of merchandise exports) of Europe(developing only) in 2004 and the Exports(as % of merchandise exports) of OECD members in 2007?
Keep it short and to the point. 1.45. What is the difference between the Exports(as % of merchandise exports) in Europe(developing only) in 2004 and the Exports(as % of merchandise exports) in Denmark in 2007?
Keep it short and to the point. -8.85. What is the difference between the Exports(as % of merchandise exports) in Europe(developing only) in 2004 and the Exports(as % of merchandise exports) in Malaysia in 2007?
Keep it short and to the point. -0.86. What is the difference between the Exports(as % of merchandise exports) of OECD members in 2004 and the Exports(as % of merchandise exports) of Denmark in 2007?
Your answer should be very brief. -10.13. What is the difference between the Exports(as % of merchandise exports) in OECD members in 2004 and the Exports(as % of merchandise exports) in Malaysia in 2007?
Your answer should be compact. -2.15. What is the difference between the Exports(as % of merchandise exports) of Denmark in 2004 and the Exports(as % of merchandise exports) of Malaysia in 2007?
Offer a terse response. 9.35. What is the difference between the Exports(as % of merchandise exports) in Europe(developing only) in 2005 and the Exports(as % of merchandise exports) in OECD members in 2006?
Keep it short and to the point. 2.43. What is the difference between the Exports(as % of merchandise exports) of Europe(developing only) in 2005 and the Exports(as % of merchandise exports) of Denmark in 2006?
Ensure brevity in your answer.  -8.42. What is the difference between the Exports(as % of merchandise exports) in Europe(developing only) in 2005 and the Exports(as % of merchandise exports) in Malaysia in 2006?
Offer a terse response. 2.12. What is the difference between the Exports(as % of merchandise exports) in OECD members in 2005 and the Exports(as % of merchandise exports) in Denmark in 2006?
Your answer should be very brief. -10.64. What is the difference between the Exports(as % of merchandise exports) of OECD members in 2005 and the Exports(as % of merchandise exports) of Malaysia in 2006?
Provide a short and direct response. -0.1. What is the difference between the Exports(as % of merchandise exports) in Denmark in 2005 and the Exports(as % of merchandise exports) in Malaysia in 2006?
Your answer should be compact. 10.76. What is the difference between the Exports(as % of merchandise exports) in Europe(developing only) in 2005 and the Exports(as % of merchandise exports) in OECD members in 2007?
Provide a succinct answer. 2.18. What is the difference between the Exports(as % of merchandise exports) of Europe(developing only) in 2005 and the Exports(as % of merchandise exports) of Denmark in 2007?
Your response must be concise. -8.12. What is the difference between the Exports(as % of merchandise exports) of Europe(developing only) in 2005 and the Exports(as % of merchandise exports) of Malaysia in 2007?
Give a very brief answer. -0.13. What is the difference between the Exports(as % of merchandise exports) in OECD members in 2005 and the Exports(as % of merchandise exports) in Denmark in 2007?
Give a very brief answer. -10.34. What is the difference between the Exports(as % of merchandise exports) of OECD members in 2005 and the Exports(as % of merchandise exports) of Malaysia in 2007?
Provide a short and direct response. -2.36. What is the difference between the Exports(as % of merchandise exports) of Denmark in 2005 and the Exports(as % of merchandise exports) of Malaysia in 2007?
Offer a terse response. 8.5. What is the difference between the Exports(as % of merchandise exports) of Europe(developing only) in 2006 and the Exports(as % of merchandise exports) of OECD members in 2007?
Your answer should be compact. 1.45. What is the difference between the Exports(as % of merchandise exports) in Europe(developing only) in 2006 and the Exports(as % of merchandise exports) in Denmark in 2007?
Your answer should be compact. -8.85. What is the difference between the Exports(as % of merchandise exports) in Europe(developing only) in 2006 and the Exports(as % of merchandise exports) in Malaysia in 2007?
Your answer should be very brief. -0.86. What is the difference between the Exports(as % of merchandise exports) in OECD members in 2006 and the Exports(as % of merchandise exports) in Denmark in 2007?
Offer a very short reply. -10.55. What is the difference between the Exports(as % of merchandise exports) of OECD members in 2006 and the Exports(as % of merchandise exports) of Malaysia in 2007?
Give a very brief answer. -2.57. What is the difference between the Exports(as % of merchandise exports) in Denmark in 2006 and the Exports(as % of merchandise exports) in Malaysia in 2007?
Offer a terse response. 8.28. What is the average Exports(as % of merchandise exports) in Europe(developing only) per year?
Your response must be concise. 8.97. What is the average Exports(as % of merchandise exports) in OECD members per year?
Offer a very short reply. 7.04. What is the average Exports(as % of merchandise exports) of Denmark per year?
Offer a very short reply. 18.7. What is the average Exports(as % of merchandise exports) of Malaysia per year?
Your answer should be very brief. 7.35. In the year 2000, what is the difference between the Exports(as % of merchandise exports) in Europe(developing only) and Exports(as % of merchandise exports) in OECD members?
Make the answer very short. 2.49. In the year 2000, what is the difference between the Exports(as % of merchandise exports) in Europe(developing only) and Exports(as % of merchandise exports) in Denmark?
Offer a terse response. -10.33. In the year 2000, what is the difference between the Exports(as % of merchandise exports) in Europe(developing only) and Exports(as % of merchandise exports) in Malaysia?
Offer a terse response. 3.84. In the year 2000, what is the difference between the Exports(as % of merchandise exports) of OECD members and Exports(as % of merchandise exports) of Denmark?
Your answer should be very brief. -12.81. In the year 2000, what is the difference between the Exports(as % of merchandise exports) of OECD members and Exports(as % of merchandise exports) of Malaysia?
Offer a very short reply. 1.35. In the year 2000, what is the difference between the Exports(as % of merchandise exports) in Denmark and Exports(as % of merchandise exports) in Malaysia?
Give a very brief answer. 14.17. In the year 2001, what is the difference between the Exports(as % of merchandise exports) of Europe(developing only) and Exports(as % of merchandise exports) of OECD members?
Give a very brief answer. 2.67. In the year 2001, what is the difference between the Exports(as % of merchandise exports) in Europe(developing only) and Exports(as % of merchandise exports) in Denmark?
Offer a terse response. -10.3. In the year 2001, what is the difference between the Exports(as % of merchandise exports) of Europe(developing only) and Exports(as % of merchandise exports) of Malaysia?
Keep it short and to the point. 3.79. In the year 2001, what is the difference between the Exports(as % of merchandise exports) in OECD members and Exports(as % of merchandise exports) in Denmark?
Offer a terse response. -12.97. In the year 2001, what is the difference between the Exports(as % of merchandise exports) in OECD members and Exports(as % of merchandise exports) in Malaysia?
Make the answer very short. 1.12. In the year 2001, what is the difference between the Exports(as % of merchandise exports) in Denmark and Exports(as % of merchandise exports) in Malaysia?
Your response must be concise. 14.09. In the year 2002, what is the difference between the Exports(as % of merchandise exports) in Europe(developing only) and Exports(as % of merchandise exports) in OECD members?
Ensure brevity in your answer.  2.07. In the year 2002, what is the difference between the Exports(as % of merchandise exports) of Europe(developing only) and Exports(as % of merchandise exports) of Denmark?
Your answer should be very brief. -10. In the year 2002, what is the difference between the Exports(as % of merchandise exports) of Europe(developing only) and Exports(as % of merchandise exports) of Malaysia?
Offer a very short reply. 1.89. In the year 2002, what is the difference between the Exports(as % of merchandise exports) in OECD members and Exports(as % of merchandise exports) in Denmark?
Give a very brief answer. -12.07. In the year 2002, what is the difference between the Exports(as % of merchandise exports) of OECD members and Exports(as % of merchandise exports) of Malaysia?
Make the answer very short. -0.18. In the year 2002, what is the difference between the Exports(as % of merchandise exports) in Denmark and Exports(as % of merchandise exports) in Malaysia?
Provide a short and direct response. 11.89. In the year 2003, what is the difference between the Exports(as % of merchandise exports) of Europe(developing only) and Exports(as % of merchandise exports) of OECD members?
Offer a terse response. 1.54. In the year 2003, what is the difference between the Exports(as % of merchandise exports) in Europe(developing only) and Exports(as % of merchandise exports) in Denmark?
Ensure brevity in your answer.  -10.41. In the year 2003, what is the difference between the Exports(as % of merchandise exports) in Europe(developing only) and Exports(as % of merchandise exports) in Malaysia?
Ensure brevity in your answer.  0.28. In the year 2003, what is the difference between the Exports(as % of merchandise exports) in OECD members and Exports(as % of merchandise exports) in Denmark?
Your response must be concise. -11.94. In the year 2003, what is the difference between the Exports(as % of merchandise exports) in OECD members and Exports(as % of merchandise exports) in Malaysia?
Make the answer very short. -1.26. In the year 2003, what is the difference between the Exports(as % of merchandise exports) of Denmark and Exports(as % of merchandise exports) of Malaysia?
Your answer should be compact. 10.68. In the year 2004, what is the difference between the Exports(as % of merchandise exports) in Europe(developing only) and Exports(as % of merchandise exports) in OECD members?
Provide a succinct answer. 1.29. In the year 2004, what is the difference between the Exports(as % of merchandise exports) in Europe(developing only) and Exports(as % of merchandise exports) in Denmark?
Offer a terse response. -10.22. In the year 2004, what is the difference between the Exports(as % of merchandise exports) of Europe(developing only) and Exports(as % of merchandise exports) of Malaysia?
Provide a succinct answer. 0.41. In the year 2004, what is the difference between the Exports(as % of merchandise exports) in OECD members and Exports(as % of merchandise exports) in Denmark?
Make the answer very short. -11.5. In the year 2004, what is the difference between the Exports(as % of merchandise exports) in OECD members and Exports(as % of merchandise exports) in Malaysia?
Keep it short and to the point. -0.87. In the year 2004, what is the difference between the Exports(as % of merchandise exports) of Denmark and Exports(as % of merchandise exports) of Malaysia?
Make the answer very short. 10.63. In the year 2005, what is the difference between the Exports(as % of merchandise exports) of Europe(developing only) and Exports(as % of merchandise exports) of OECD members?
Ensure brevity in your answer.  2.22. In the year 2005, what is the difference between the Exports(as % of merchandise exports) in Europe(developing only) and Exports(as % of merchandise exports) in Denmark?
Give a very brief answer. -8.63. In the year 2005, what is the difference between the Exports(as % of merchandise exports) in Europe(developing only) and Exports(as % of merchandise exports) in Malaysia?
Offer a very short reply. 2.15. In the year 2005, what is the difference between the Exports(as % of merchandise exports) of OECD members and Exports(as % of merchandise exports) of Denmark?
Ensure brevity in your answer.  -10.85. In the year 2005, what is the difference between the Exports(as % of merchandise exports) in OECD members and Exports(as % of merchandise exports) in Malaysia?
Provide a short and direct response. -0.07. In the year 2005, what is the difference between the Exports(as % of merchandise exports) in Denmark and Exports(as % of merchandise exports) in Malaysia?
Make the answer very short. 10.78. In the year 2006, what is the difference between the Exports(as % of merchandise exports) in Europe(developing only) and Exports(as % of merchandise exports) in OECD members?
Provide a short and direct response. 1.7. In the year 2006, what is the difference between the Exports(as % of merchandise exports) of Europe(developing only) and Exports(as % of merchandise exports) of Denmark?
Give a very brief answer. -9.15. In the year 2006, what is the difference between the Exports(as % of merchandise exports) of Europe(developing only) and Exports(as % of merchandise exports) of Malaysia?
Your response must be concise. 1.39. In the year 2006, what is the difference between the Exports(as % of merchandise exports) of OECD members and Exports(as % of merchandise exports) of Denmark?
Provide a succinct answer. -10.85. In the year 2006, what is the difference between the Exports(as % of merchandise exports) in OECD members and Exports(as % of merchandise exports) in Malaysia?
Your answer should be compact. -0.31. In the year 2006, what is the difference between the Exports(as % of merchandise exports) in Denmark and Exports(as % of merchandise exports) in Malaysia?
Keep it short and to the point. 10.54. In the year 2007, what is the difference between the Exports(as % of merchandise exports) in Europe(developing only) and Exports(as % of merchandise exports) in OECD members?
Make the answer very short. 1.53. In the year 2007, what is the difference between the Exports(as % of merchandise exports) in Europe(developing only) and Exports(as % of merchandise exports) in Denmark?
Offer a terse response. -8.77. In the year 2007, what is the difference between the Exports(as % of merchandise exports) in Europe(developing only) and Exports(as % of merchandise exports) in Malaysia?
Ensure brevity in your answer.  -0.79. In the year 2007, what is the difference between the Exports(as % of merchandise exports) of OECD members and Exports(as % of merchandise exports) of Denmark?
Offer a terse response. -10.3. In the year 2007, what is the difference between the Exports(as % of merchandise exports) of OECD members and Exports(as % of merchandise exports) of Malaysia?
Offer a very short reply. -2.32. In the year 2007, what is the difference between the Exports(as % of merchandise exports) of Denmark and Exports(as % of merchandise exports) of Malaysia?
Your response must be concise. 7.98. What is the ratio of the Exports(as % of merchandise exports) of Europe(developing only) in 2000 to that in 2001?
Make the answer very short. 0.95. What is the ratio of the Exports(as % of merchandise exports) in OECD members in 2000 to that in 2001?
Offer a terse response. 0.96. What is the ratio of the Exports(as % of merchandise exports) in Denmark in 2000 to that in 2001?
Your response must be concise. 0.98. What is the ratio of the Exports(as % of merchandise exports) of Malaysia in 2000 to that in 2001?
Ensure brevity in your answer.  0.91. What is the ratio of the Exports(as % of merchandise exports) in OECD members in 2000 to that in 2002?
Your answer should be compact. 0.94. What is the ratio of the Exports(as % of merchandise exports) in Denmark in 2000 to that in 2002?
Offer a very short reply. 1.02. What is the ratio of the Exports(as % of merchandise exports) of Malaysia in 2000 to that in 2002?
Provide a succinct answer. 0.74. What is the ratio of the Exports(as % of merchandise exports) in Europe(developing only) in 2000 to that in 2003?
Provide a succinct answer. 1.06. What is the ratio of the Exports(as % of merchandise exports) of OECD members in 2000 to that in 2003?
Provide a short and direct response. 0.94. What is the ratio of the Exports(as % of merchandise exports) in Denmark in 2000 to that in 2003?
Your answer should be compact. 1.02. What is the ratio of the Exports(as % of merchandise exports) in Malaysia in 2000 to that in 2003?
Provide a short and direct response. 0.64. What is the ratio of the Exports(as % of merchandise exports) of Europe(developing only) in 2000 to that in 2004?
Provide a succinct answer. 1.12. What is the ratio of the Exports(as % of merchandise exports) of OECD members in 2000 to that in 2004?
Your answer should be compact. 0.97. What is the ratio of the Exports(as % of merchandise exports) in Denmark in 2000 to that in 2004?
Give a very brief answer. 1.06. What is the ratio of the Exports(as % of merchandise exports) of Malaysia in 2000 to that in 2004?
Keep it short and to the point. 0.7. What is the ratio of the Exports(as % of merchandise exports) in Europe(developing only) in 2000 to that in 2005?
Make the answer very short. 1.03. What is the ratio of the Exports(as % of merchandise exports) in Denmark in 2000 to that in 2005?
Ensure brevity in your answer.  1.11. What is the ratio of the Exports(as % of merchandise exports) of Malaysia in 2000 to that in 2005?
Offer a very short reply. 0.8. What is the ratio of the Exports(as % of merchandise exports) of Europe(developing only) in 2000 to that in 2006?
Your answer should be very brief. 1.12. What is the ratio of the Exports(as % of merchandise exports) in OECD members in 2000 to that in 2006?
Offer a terse response. 1.03. What is the ratio of the Exports(as % of merchandise exports) in Denmark in 2000 to that in 2006?
Ensure brevity in your answer.  1.12. What is the ratio of the Exports(as % of merchandise exports) in Malaysia in 2000 to that in 2006?
Ensure brevity in your answer.  0.79. What is the ratio of the Exports(as % of merchandise exports) in Europe(developing only) in 2000 to that in 2007?
Your answer should be very brief. 1.11. What is the ratio of the Exports(as % of merchandise exports) of Denmark in 2000 to that in 2007?
Make the answer very short. 1.14. What is the ratio of the Exports(as % of merchandise exports) of Malaysia in 2000 to that in 2007?
Offer a terse response. 0.6. What is the ratio of the Exports(as % of merchandise exports) of Europe(developing only) in 2001 to that in 2002?
Provide a succinct answer. 1.05. What is the ratio of the Exports(as % of merchandise exports) of OECD members in 2001 to that in 2002?
Give a very brief answer. 0.98. What is the ratio of the Exports(as % of merchandise exports) of Denmark in 2001 to that in 2002?
Ensure brevity in your answer.  1.04. What is the ratio of the Exports(as % of merchandise exports) of Malaysia in 2001 to that in 2002?
Provide a succinct answer. 0.81. What is the ratio of the Exports(as % of merchandise exports) of Europe(developing only) in 2001 to that in 2003?
Offer a very short reply. 1.11. What is the ratio of the Exports(as % of merchandise exports) in OECD members in 2001 to that in 2003?
Make the answer very short. 0.98. What is the ratio of the Exports(as % of merchandise exports) of Denmark in 2001 to that in 2003?
Keep it short and to the point. 1.04. What is the ratio of the Exports(as % of merchandise exports) in Malaysia in 2001 to that in 2003?
Your answer should be very brief. 0.7. What is the ratio of the Exports(as % of merchandise exports) in Europe(developing only) in 2001 to that in 2004?
Keep it short and to the point. 1.18. What is the ratio of the Exports(as % of merchandise exports) of OECD members in 2001 to that in 2004?
Offer a very short reply. 1.01. What is the ratio of the Exports(as % of merchandise exports) in Denmark in 2001 to that in 2004?
Give a very brief answer. 1.08. What is the ratio of the Exports(as % of merchandise exports) of Malaysia in 2001 to that in 2004?
Offer a terse response. 0.76. What is the ratio of the Exports(as % of merchandise exports) in Europe(developing only) in 2001 to that in 2005?
Keep it short and to the point. 1.08. What is the ratio of the Exports(as % of merchandise exports) of OECD members in 2001 to that in 2005?
Your answer should be compact. 1.04. What is the ratio of the Exports(as % of merchandise exports) of Denmark in 2001 to that in 2005?
Provide a succinct answer. 1.14. What is the ratio of the Exports(as % of merchandise exports) in Malaysia in 2001 to that in 2005?
Give a very brief answer. 0.87. What is the ratio of the Exports(as % of merchandise exports) in Europe(developing only) in 2001 to that in 2006?
Give a very brief answer. 1.18. What is the ratio of the Exports(as % of merchandise exports) of OECD members in 2001 to that in 2006?
Keep it short and to the point. 1.08. What is the ratio of the Exports(as % of merchandise exports) of Denmark in 2001 to that in 2006?
Your answer should be compact. 1.15. What is the ratio of the Exports(as % of merchandise exports) of Malaysia in 2001 to that in 2006?
Your answer should be compact. 0.87. What is the ratio of the Exports(as % of merchandise exports) of Europe(developing only) in 2001 to that in 2007?
Give a very brief answer. 1.17. What is the ratio of the Exports(as % of merchandise exports) of OECD members in 2001 to that in 2007?
Offer a very short reply. 1.04. What is the ratio of the Exports(as % of merchandise exports) in Denmark in 2001 to that in 2007?
Your answer should be very brief. 1.17. What is the ratio of the Exports(as % of merchandise exports) in Malaysia in 2001 to that in 2007?
Make the answer very short. 0.66. What is the ratio of the Exports(as % of merchandise exports) in Europe(developing only) in 2002 to that in 2003?
Keep it short and to the point. 1.06. What is the ratio of the Exports(as % of merchandise exports) of OECD members in 2002 to that in 2003?
Make the answer very short. 0.99. What is the ratio of the Exports(as % of merchandise exports) in Denmark in 2002 to that in 2003?
Ensure brevity in your answer.  1. What is the ratio of the Exports(as % of merchandise exports) in Malaysia in 2002 to that in 2003?
Your response must be concise. 0.87. What is the ratio of the Exports(as % of merchandise exports) in Europe(developing only) in 2002 to that in 2004?
Your answer should be very brief. 1.12. What is the ratio of the Exports(as % of merchandise exports) in OECD members in 2002 to that in 2004?
Make the answer very short. 1.03. What is the ratio of the Exports(as % of merchandise exports) of Denmark in 2002 to that in 2004?
Offer a terse response. 1.04. What is the ratio of the Exports(as % of merchandise exports) in Malaysia in 2002 to that in 2004?
Your answer should be compact. 0.94. What is the ratio of the Exports(as % of merchandise exports) of Europe(developing only) in 2002 to that in 2005?
Keep it short and to the point. 1.03. What is the ratio of the Exports(as % of merchandise exports) of OECD members in 2002 to that in 2005?
Give a very brief answer. 1.06. What is the ratio of the Exports(as % of merchandise exports) in Denmark in 2002 to that in 2005?
Make the answer very short. 1.09. What is the ratio of the Exports(as % of merchandise exports) in Malaysia in 2002 to that in 2005?
Provide a short and direct response. 1.08. What is the ratio of the Exports(as % of merchandise exports) in Europe(developing only) in 2002 to that in 2006?
Provide a succinct answer. 1.12. What is the ratio of the Exports(as % of merchandise exports) of OECD members in 2002 to that in 2006?
Provide a succinct answer. 1.1. What is the ratio of the Exports(as % of merchandise exports) in Denmark in 2002 to that in 2006?
Offer a very short reply. 1.11. What is the ratio of the Exports(as % of merchandise exports) in Malaysia in 2002 to that in 2006?
Your response must be concise. 1.07. What is the ratio of the Exports(as % of merchandise exports) of Europe(developing only) in 2002 to that in 2007?
Provide a short and direct response. 1.11. What is the ratio of the Exports(as % of merchandise exports) of OECD members in 2002 to that in 2007?
Give a very brief answer. 1.06. What is the ratio of the Exports(as % of merchandise exports) of Denmark in 2002 to that in 2007?
Your answer should be compact. 1.13. What is the ratio of the Exports(as % of merchandise exports) of Malaysia in 2002 to that in 2007?
Your response must be concise. 0.81. What is the ratio of the Exports(as % of merchandise exports) of Europe(developing only) in 2003 to that in 2004?
Ensure brevity in your answer.  1.06. What is the ratio of the Exports(as % of merchandise exports) in Denmark in 2003 to that in 2004?
Your answer should be very brief. 1.04. What is the ratio of the Exports(as % of merchandise exports) of Malaysia in 2003 to that in 2004?
Keep it short and to the point. 1.08. What is the ratio of the Exports(as % of merchandise exports) in OECD members in 2003 to that in 2005?
Offer a terse response. 1.07. What is the ratio of the Exports(as % of merchandise exports) of Denmark in 2003 to that in 2005?
Make the answer very short. 1.09. What is the ratio of the Exports(as % of merchandise exports) in Malaysia in 2003 to that in 2005?
Keep it short and to the point. 1.24. What is the ratio of the Exports(as % of merchandise exports) of Europe(developing only) in 2003 to that in 2006?
Provide a short and direct response. 1.06. What is the ratio of the Exports(as % of merchandise exports) of OECD members in 2003 to that in 2006?
Offer a terse response. 1.1. What is the ratio of the Exports(as % of merchandise exports) of Denmark in 2003 to that in 2006?
Provide a succinct answer. 1.1. What is the ratio of the Exports(as % of merchandise exports) in Malaysia in 2003 to that in 2006?
Your answer should be compact. 1.23. What is the ratio of the Exports(as % of merchandise exports) in Europe(developing only) in 2003 to that in 2007?
Your answer should be compact. 1.05. What is the ratio of the Exports(as % of merchandise exports) in OECD members in 2003 to that in 2007?
Make the answer very short. 1.06. What is the ratio of the Exports(as % of merchandise exports) of Denmark in 2003 to that in 2007?
Your answer should be very brief. 1.12. What is the ratio of the Exports(as % of merchandise exports) in Malaysia in 2003 to that in 2007?
Keep it short and to the point. 0.93. What is the ratio of the Exports(as % of merchandise exports) of OECD members in 2004 to that in 2005?
Your response must be concise. 1.03. What is the ratio of the Exports(as % of merchandise exports) in Denmark in 2004 to that in 2005?
Give a very brief answer. 1.05. What is the ratio of the Exports(as % of merchandise exports) in Malaysia in 2004 to that in 2005?
Offer a terse response. 1.15. What is the ratio of the Exports(as % of merchandise exports) of Europe(developing only) in 2004 to that in 2006?
Provide a short and direct response. 1. What is the ratio of the Exports(as % of merchandise exports) in OECD members in 2004 to that in 2006?
Offer a terse response. 1.06. What is the ratio of the Exports(as % of merchandise exports) in Denmark in 2004 to that in 2006?
Your answer should be very brief. 1.06. What is the ratio of the Exports(as % of merchandise exports) of Malaysia in 2004 to that in 2006?
Provide a short and direct response. 1.14. What is the ratio of the Exports(as % of merchandise exports) in Europe(developing only) in 2004 to that in 2007?
Offer a terse response. 0.99. What is the ratio of the Exports(as % of merchandise exports) in OECD members in 2004 to that in 2007?
Your answer should be compact. 1.02. What is the ratio of the Exports(as % of merchandise exports) of Denmark in 2004 to that in 2007?
Ensure brevity in your answer.  1.08. What is the ratio of the Exports(as % of merchandise exports) of Malaysia in 2004 to that in 2007?
Offer a very short reply. 0.86. What is the ratio of the Exports(as % of merchandise exports) in Europe(developing only) in 2005 to that in 2006?
Give a very brief answer. 1.09. What is the ratio of the Exports(as % of merchandise exports) of OECD members in 2005 to that in 2006?
Offer a terse response. 1.03. What is the ratio of the Exports(as % of merchandise exports) in Denmark in 2005 to that in 2006?
Offer a very short reply. 1.01. What is the ratio of the Exports(as % of merchandise exports) of Malaysia in 2005 to that in 2006?
Your answer should be very brief. 1. What is the ratio of the Exports(as % of merchandise exports) of Europe(developing only) in 2005 to that in 2007?
Your answer should be very brief. 1.08. What is the ratio of the Exports(as % of merchandise exports) in OECD members in 2005 to that in 2007?
Ensure brevity in your answer.  0.99. What is the ratio of the Exports(as % of merchandise exports) of Denmark in 2005 to that in 2007?
Offer a very short reply. 1.03. What is the ratio of the Exports(as % of merchandise exports) in Malaysia in 2005 to that in 2007?
Ensure brevity in your answer.  0.75. What is the ratio of the Exports(as % of merchandise exports) in Europe(developing only) in 2006 to that in 2007?
Offer a terse response. 0.99. What is the ratio of the Exports(as % of merchandise exports) in OECD members in 2006 to that in 2007?
Offer a very short reply. 0.96. What is the ratio of the Exports(as % of merchandise exports) of Denmark in 2006 to that in 2007?
Keep it short and to the point. 1.02. What is the ratio of the Exports(as % of merchandise exports) in Malaysia in 2006 to that in 2007?
Your answer should be compact. 0.76. What is the difference between the highest and the second highest Exports(as % of merchandise exports) of Europe(developing only)?
Keep it short and to the point. 0.46. What is the difference between the highest and the second highest Exports(as % of merchandise exports) in OECD members?
Provide a succinct answer. 0.04. What is the difference between the highest and the second highest Exports(as % of merchandise exports) in Denmark?
Your answer should be compact. 0.44. What is the difference between the highest and the second highest Exports(as % of merchandise exports) of Malaysia?
Your answer should be very brief. 0.63. What is the difference between the highest and the lowest Exports(as % of merchandise exports) in Europe(developing only)?
Ensure brevity in your answer.  1.47. What is the difference between the highest and the lowest Exports(as % of merchandise exports) of OECD members?
Your response must be concise. 0.68. What is the difference between the highest and the lowest Exports(as % of merchandise exports) in Denmark?
Give a very brief answer. 2.93. What is the difference between the highest and the lowest Exports(as % of merchandise exports) of Malaysia?
Provide a succinct answer. 3.7. 